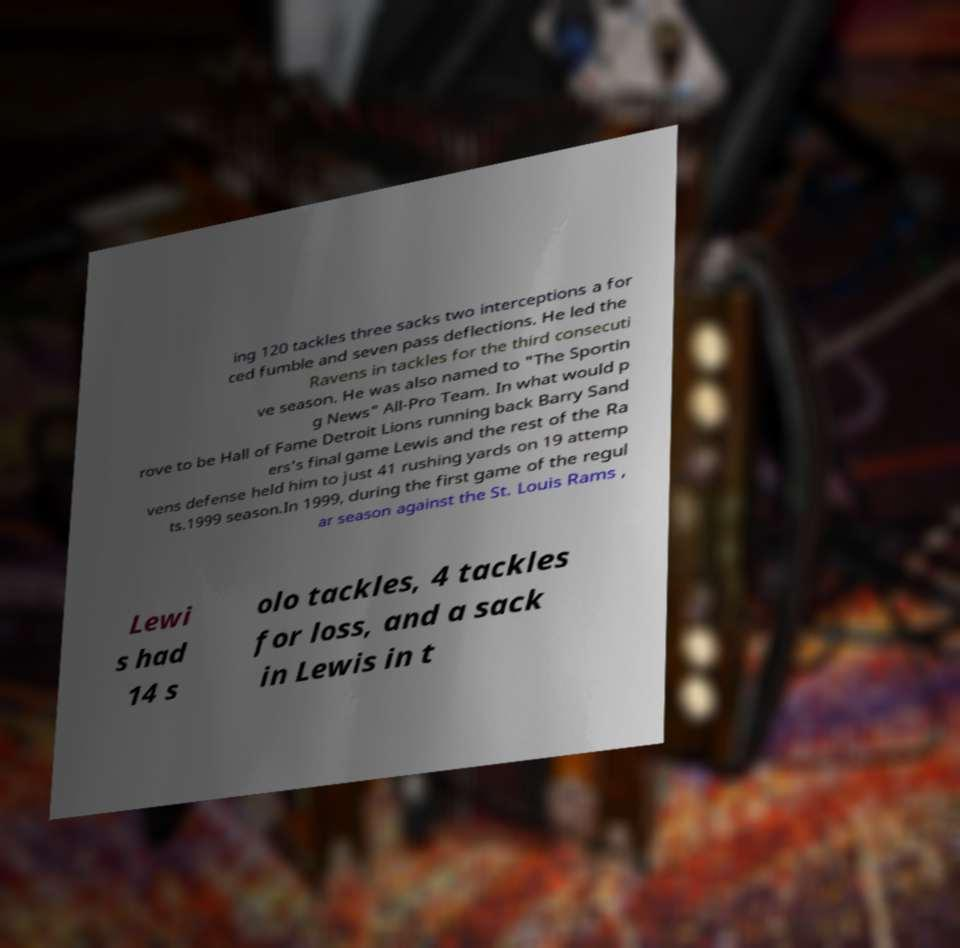Could you extract and type out the text from this image? ing 120 tackles three sacks two interceptions a for ced fumble and seven pass deflections. He led the Ravens in tackles for the third consecuti ve season. He was also named to "The Sportin g News" All-Pro Team. In what would p rove to be Hall of Fame Detroit Lions running back Barry Sand ers's final game Lewis and the rest of the Ra vens defense held him to just 41 rushing yards on 19 attemp ts.1999 season.In 1999, during the first game of the regul ar season against the St. Louis Rams , Lewi s had 14 s olo tackles, 4 tackles for loss, and a sack in Lewis in t 